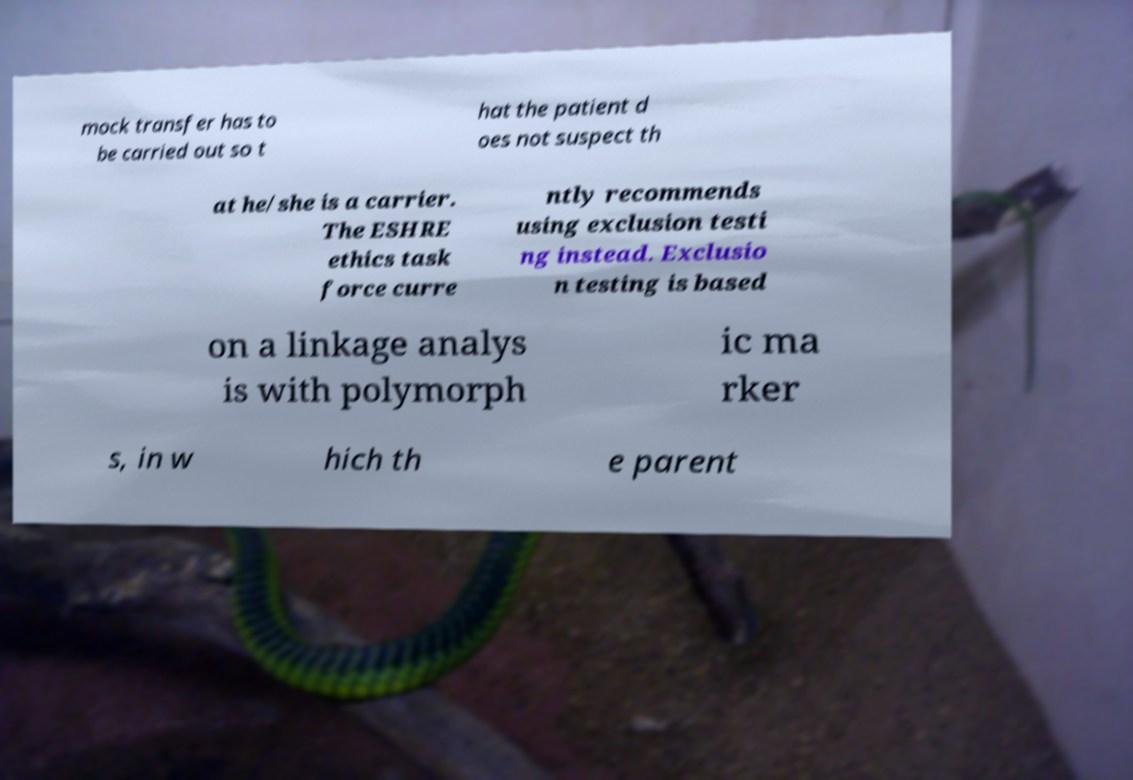What messages or text are displayed in this image? I need them in a readable, typed format. mock transfer has to be carried out so t hat the patient d oes not suspect th at he/she is a carrier. The ESHRE ethics task force curre ntly recommends using exclusion testi ng instead. Exclusio n testing is based on a linkage analys is with polymorph ic ma rker s, in w hich th e parent 